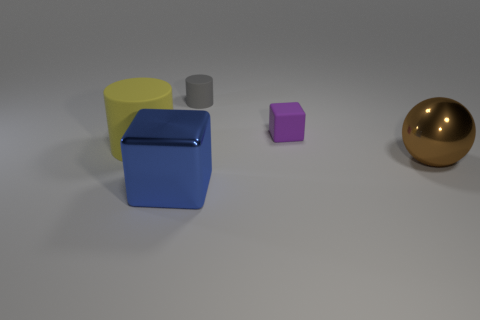What is the size of the yellow object that is the same shape as the gray rubber thing?
Offer a very short reply. Large. What is the large brown ball made of?
Your answer should be compact. Metal. Is the block in front of the purple thing made of the same material as the big sphere?
Offer a terse response. Yes. Is the number of small gray things that are to the left of the big blue metallic thing less than the number of big brown shiny balls?
Provide a succinct answer. Yes. What is the color of the metallic sphere that is the same size as the yellow rubber cylinder?
Offer a terse response. Brown. What number of purple things have the same shape as the yellow matte object?
Offer a very short reply. 0. What is the color of the small matte thing that is behind the rubber block?
Your answer should be very brief. Gray. How many matte things are large yellow cylinders or tiny purple things?
Your answer should be very brief. 2. What number of brown metal objects have the same size as the purple object?
Provide a succinct answer. 0. What color is the rubber thing that is to the left of the small purple rubber thing and in front of the tiny rubber cylinder?
Provide a short and direct response. Yellow. 